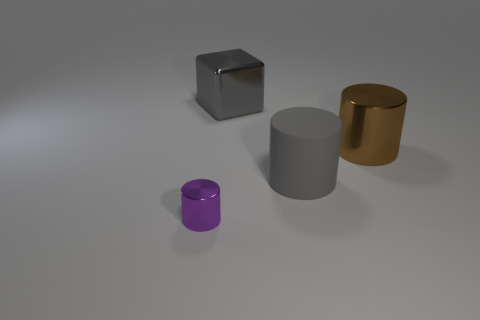Are there any other things that have the same size as the purple metallic cylinder?
Provide a succinct answer. No. There is a matte thing; is its shape the same as the metallic object in front of the gray cylinder?
Offer a very short reply. Yes. What size is the metallic thing left of the big block?
Your response must be concise. Small. What material is the large gray cube?
Give a very brief answer. Metal. There is a large object that is in front of the large shiny cylinder; is its shape the same as the small purple shiny object?
Offer a terse response. Yes. What is the size of the cylinder that is the same color as the block?
Your answer should be very brief. Large. Is there another gray cylinder that has the same size as the gray cylinder?
Provide a succinct answer. No. There is a gray thing in front of the shiny cylinder that is behind the small shiny cylinder; is there a cylinder left of it?
Provide a succinct answer. Yes. There is a tiny metallic thing; is it the same color as the shiny object that is on the right side of the large gray metal object?
Provide a short and direct response. No. What is the material of the gray thing that is right of the large metal thing that is to the left of the shiny cylinder that is on the right side of the gray block?
Provide a short and direct response. Rubber. 